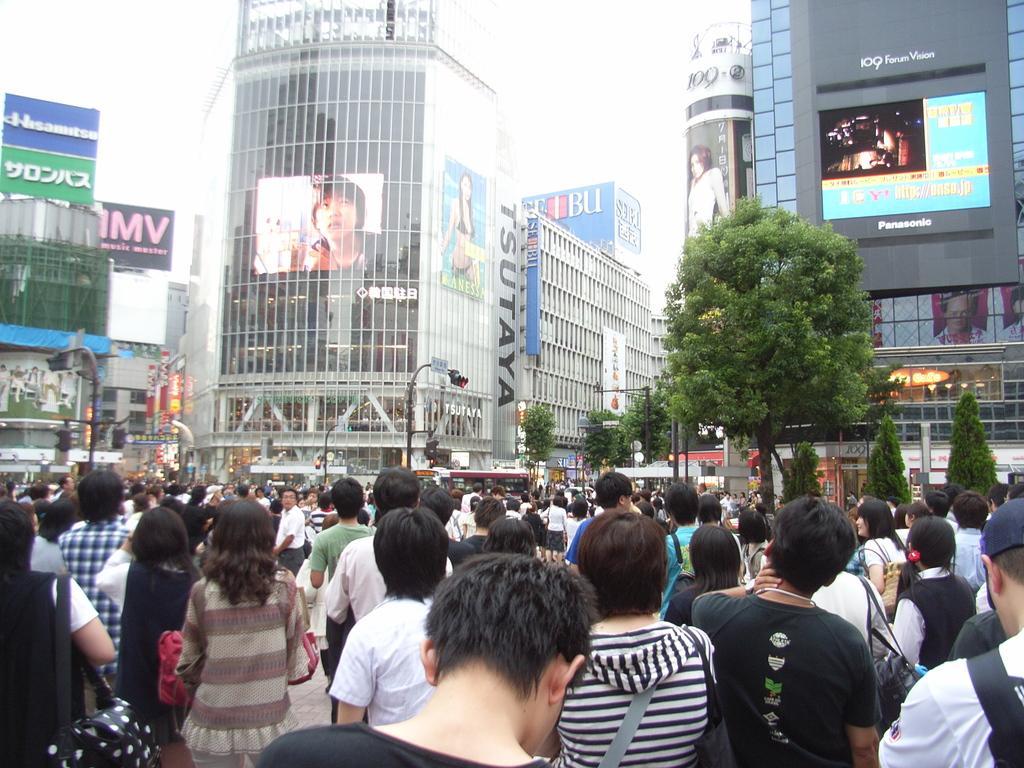In one or two sentences, can you explain what this image depicts? There are groups of people standing. These are the buildings with the windows and glass doors. This looks like a screen with the display. I can see the trees. Here is the traffic signal, which is attached to the pole. These are the hoardings, which are at the top of the building. 